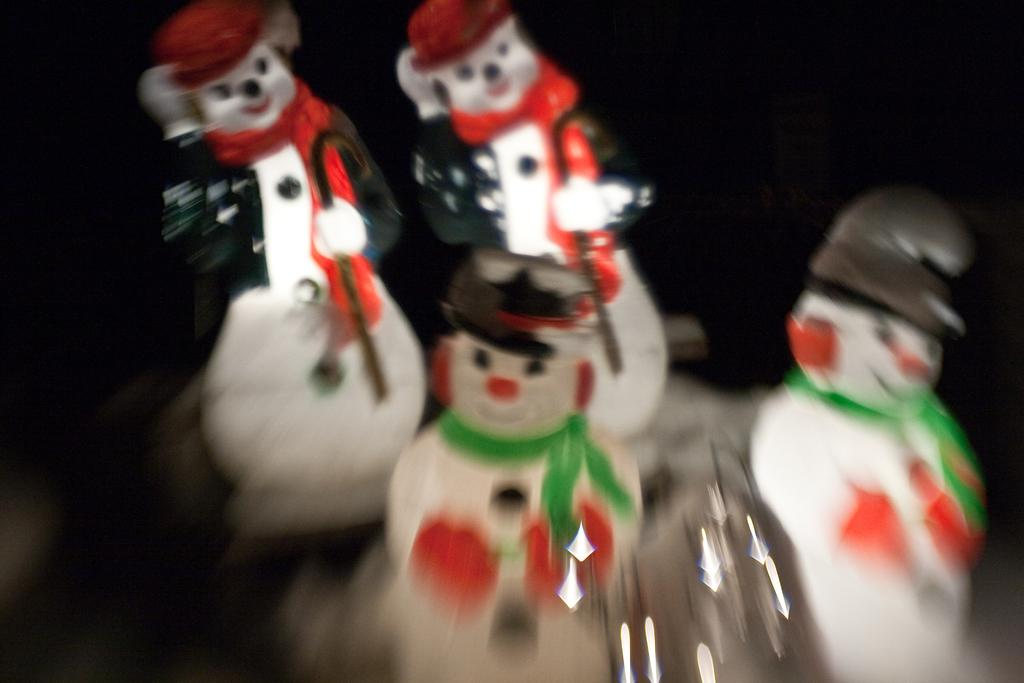What objects are present in the image? There are toys in the image. What feature do the toys have? The toys have caps. What color is the background of the image? The background of the image is black. How many shoes can be seen in the image? There are no shoes present in the image. Are the toys in the image sleeping? The toys in the image are not depicted as sleeping; they are simply shown with their caps. 